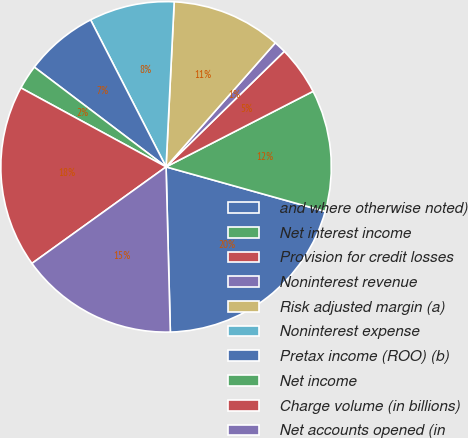Convert chart. <chart><loc_0><loc_0><loc_500><loc_500><pie_chart><fcel>and where otherwise noted)<fcel>Net interest income<fcel>Provision for credit losses<fcel>Noninterest revenue<fcel>Risk adjusted margin (a)<fcel>Noninterest expense<fcel>Pretax income (ROO) (b)<fcel>Net income<fcel>Charge volume (in billions)<fcel>Net accounts opened (in<nl><fcel>20.24%<fcel>11.9%<fcel>4.76%<fcel>1.19%<fcel>10.71%<fcel>8.33%<fcel>7.14%<fcel>2.38%<fcel>17.86%<fcel>15.48%<nl></chart> 